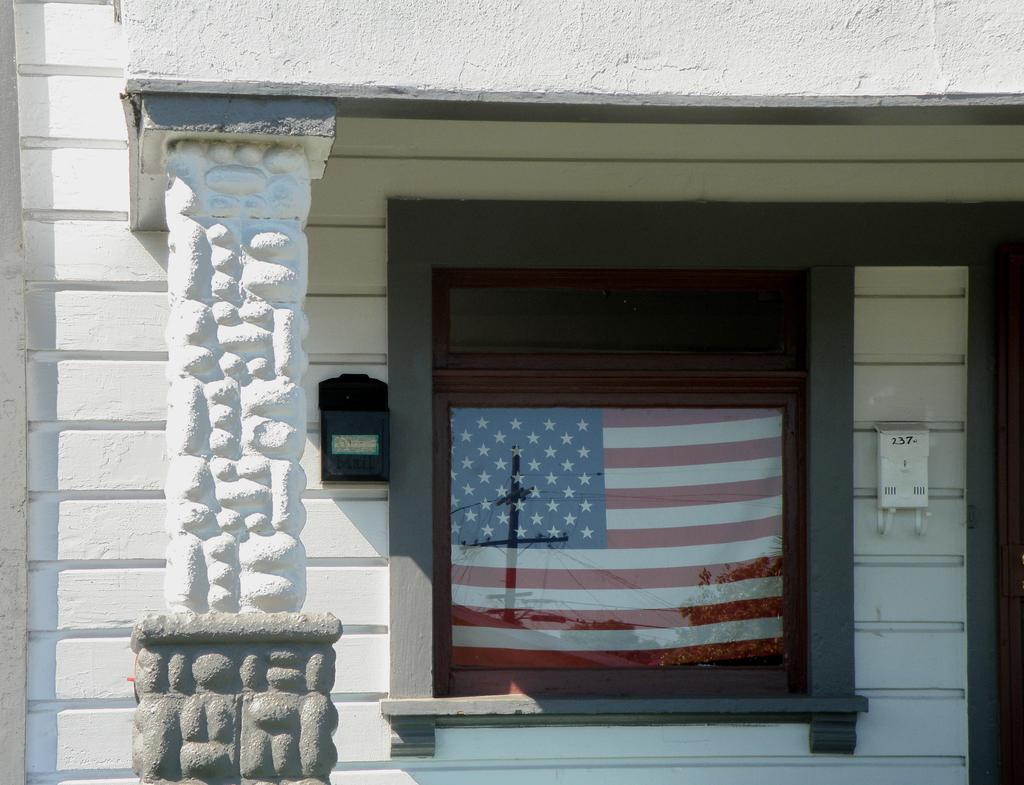What type of structure is visible in the image? There is a building in the image. What are some features of the building? The building has windows and a pillar. Is there any indication of a national or organizational affiliation in the image? Yes, there is a flag on a window glass. What can be seen on the wall inside the building? There are objects on the wall. What type of doll can be seen playing in the field outside the building? There is no doll or field present in the image; it only features a building with windows, a pillar, a flag on a window glass, and objects on the wall. 